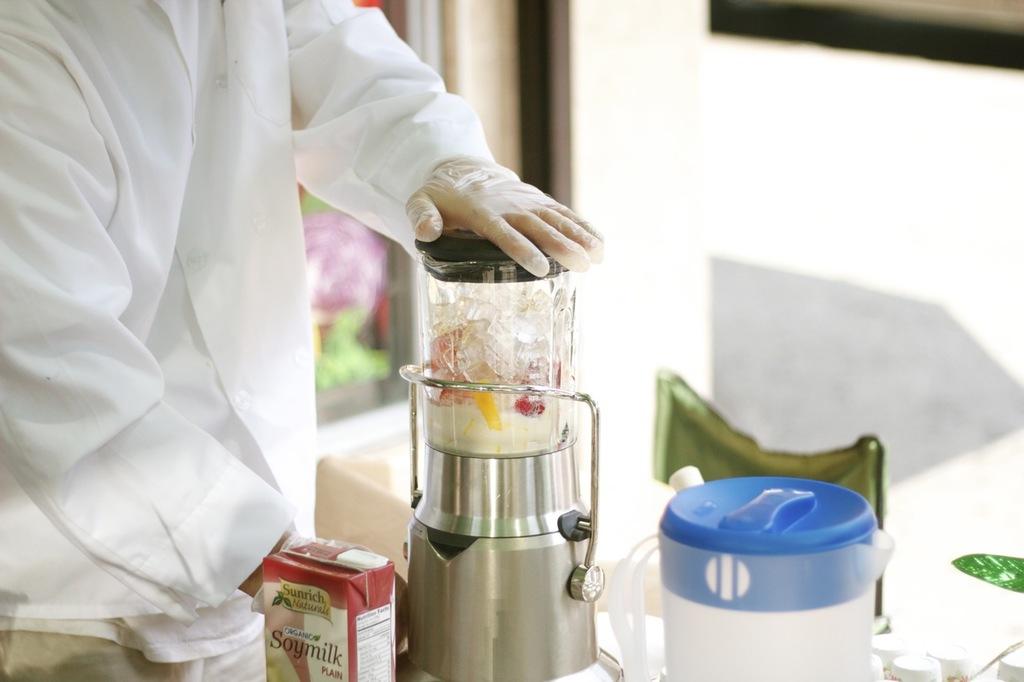What is he blending?
Provide a short and direct response. Soy milk. Is that soymilk?
Offer a terse response. Yes. 